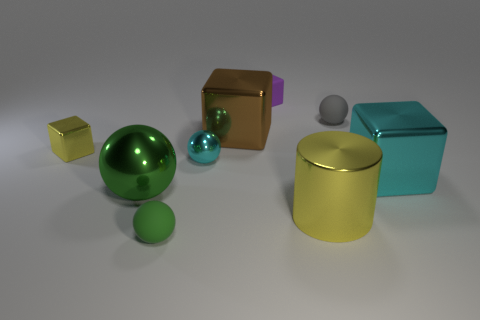Subtract all big brown blocks. How many blocks are left? 3 Subtract all yellow cubes. How many green balls are left? 2 Subtract all cyan cubes. How many cubes are left? 3 Subtract 2 blocks. How many blocks are left? 2 Subtract all balls. How many objects are left? 5 Add 2 large cyan metallic objects. How many large cyan metallic objects exist? 3 Subtract 1 purple cubes. How many objects are left? 8 Subtract all purple spheres. Subtract all brown cylinders. How many spheres are left? 4 Subtract all big cyan cylinders. Subtract all tiny green balls. How many objects are left? 8 Add 9 small green matte spheres. How many small green matte spheres are left? 10 